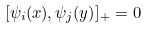<formula> <loc_0><loc_0><loc_500><loc_500>[ { \psi _ { i } ( x ) , { \psi _ { j } ( y ) } } ] _ { + } = 0</formula> 